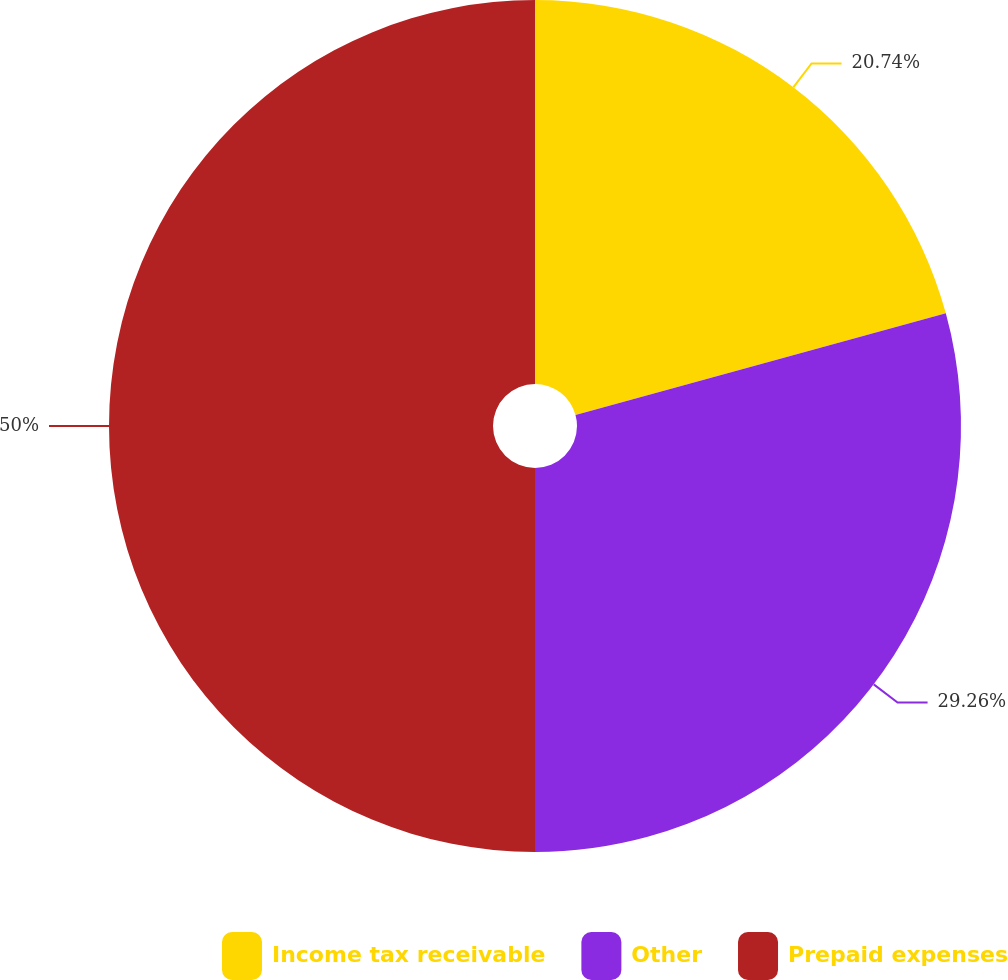Convert chart to OTSL. <chart><loc_0><loc_0><loc_500><loc_500><pie_chart><fcel>Income tax receivable<fcel>Other<fcel>Prepaid expenses<nl><fcel>20.74%<fcel>29.26%<fcel>50.0%<nl></chart> 